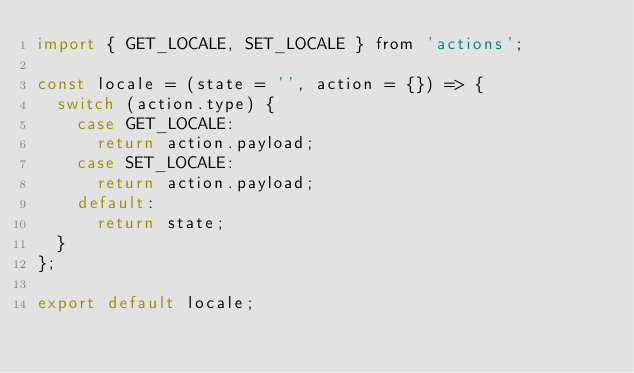<code> <loc_0><loc_0><loc_500><loc_500><_JavaScript_>import { GET_LOCALE, SET_LOCALE } from 'actions';

const locale = (state = '', action = {}) => {
  switch (action.type) {
    case GET_LOCALE:
      return action.payload;
    case SET_LOCALE:
      return action.payload;
    default:
      return state;
  }
};

export default locale;
</code> 